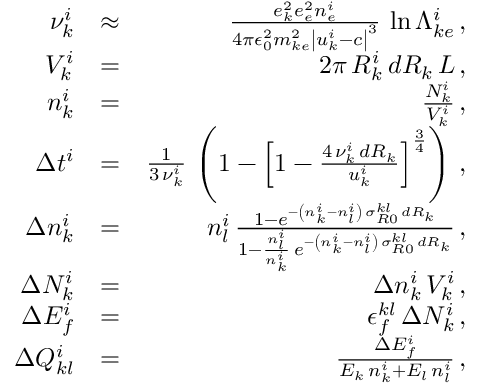<formula> <loc_0><loc_0><loc_500><loc_500>\begin{array} { r l r } { \nu _ { k } ^ { i } } & { \approx } & { \frac { e _ { k } ^ { 2 } e _ { e } ^ { 2 } n _ { e } ^ { i } } { 4 \pi \epsilon _ { 0 } ^ { 2 } m _ { k e } ^ { 2 } \left | u _ { k } ^ { i } - c \right | ^ { 3 } } \, \ln \Lambda _ { k e } ^ { i } \, , } \\ { V _ { k } ^ { i } } & { = } & { 2 \pi \, R _ { k } ^ { i } \, d R _ { k } \, L \, , } \\ { n _ { k } ^ { i } } & { = } & { \frac { N _ { k } ^ { i } } { V _ { k } ^ { i } } \, , } \\ { \Delta t ^ { i } } & { = } & { \frac { 1 } { 3 \, \nu _ { k } ^ { i } } \, \left ( 1 - \left [ 1 - \frac { 4 \, \nu _ { k } ^ { i } \, d R _ { k } } { u _ { k } ^ { i } } \right ] ^ { \frac { 3 } { 4 } } \right ) \, , } \\ { \Delta n _ { k } ^ { i } } & { = } & { n _ { l } ^ { i } \, \frac { 1 - e ^ { - \left ( n _ { k } ^ { i } - n _ { l } ^ { i } \right ) \, \sigma _ { R 0 } ^ { k l } \, d R _ { k } } } { 1 - \frac { n _ { l } ^ { i } } { n _ { k } ^ { i } } \, e ^ { - \left ( n _ { k } ^ { i } - n _ { l } ^ { i } \right ) \, \sigma _ { R 0 } ^ { k l } \, d R _ { k } } } \, , } \\ { \Delta N _ { k } ^ { i } } & { = } & { \Delta n _ { k } ^ { i } \, V _ { k } ^ { i } \, , } \\ { \Delta E _ { f } ^ { i } } & { = } & { \epsilon _ { f } ^ { k l } \, \Delta N _ { k } ^ { i } \, , } \\ { \Delta Q _ { k l } ^ { i } } & { = } & { \frac { \Delta E _ { f } ^ { i } } { E _ { k } \, n _ { k } ^ { i } + E _ { l } \, n _ { l } ^ { i } } \, , } \end{array}</formula> 